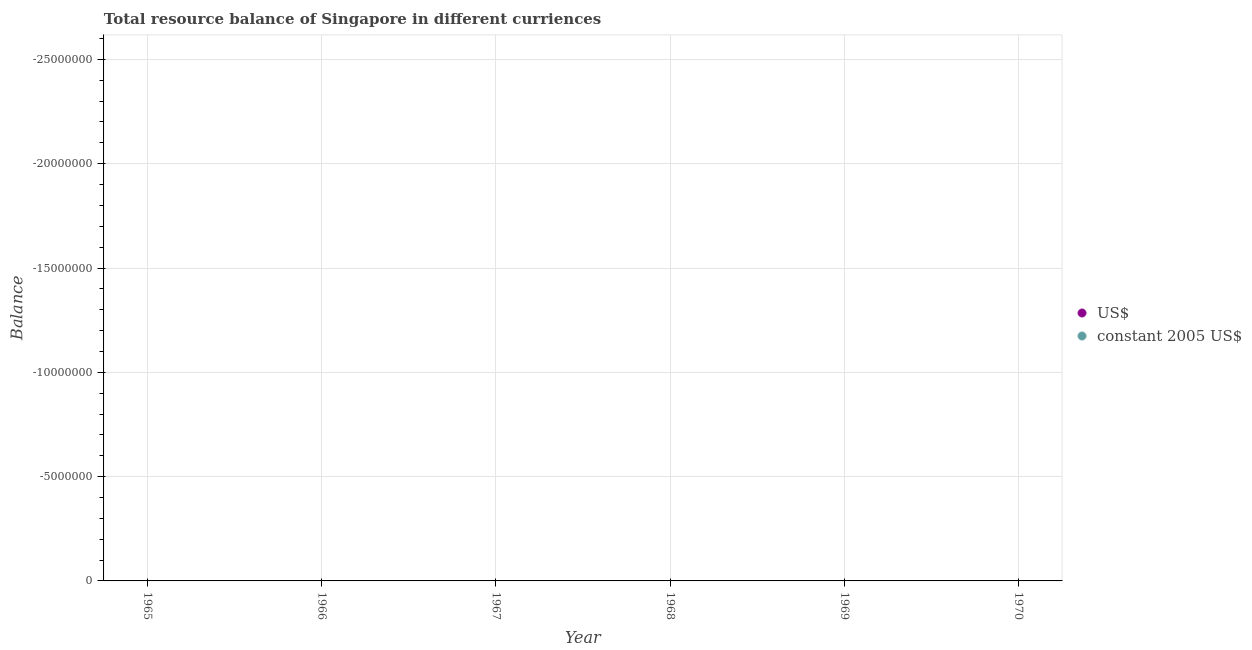Is the number of dotlines equal to the number of legend labels?
Your answer should be compact. No. What is the resource balance in us$ in 1966?
Give a very brief answer. 0. Across all years, what is the minimum resource balance in constant us$?
Offer a terse response. 0. What is the total resource balance in constant us$ in the graph?
Offer a terse response. 0. In how many years, is the resource balance in us$ greater than the average resource balance in us$ taken over all years?
Make the answer very short. 0. Does the resource balance in constant us$ monotonically increase over the years?
Provide a succinct answer. No. What is the difference between two consecutive major ticks on the Y-axis?
Provide a succinct answer. 5.00e+06. Does the graph contain any zero values?
Offer a terse response. Yes. Does the graph contain grids?
Your answer should be very brief. Yes. How many legend labels are there?
Keep it short and to the point. 2. How are the legend labels stacked?
Make the answer very short. Vertical. What is the title of the graph?
Your answer should be very brief. Total resource balance of Singapore in different curriences. Does "Banks" appear as one of the legend labels in the graph?
Ensure brevity in your answer.  No. What is the label or title of the Y-axis?
Your answer should be compact. Balance. What is the Balance of US$ in 1965?
Ensure brevity in your answer.  0. What is the Balance in constant 2005 US$ in 1965?
Provide a short and direct response. 0. What is the Balance of US$ in 1967?
Keep it short and to the point. 0. What is the Balance in constant 2005 US$ in 1969?
Provide a succinct answer. 0. What is the Balance in US$ in 1970?
Provide a short and direct response. 0. What is the Balance of constant 2005 US$ in 1970?
Your answer should be compact. 0. What is the total Balance of US$ in the graph?
Ensure brevity in your answer.  0. What is the average Balance in US$ per year?
Keep it short and to the point. 0. What is the average Balance of constant 2005 US$ per year?
Give a very brief answer. 0. 